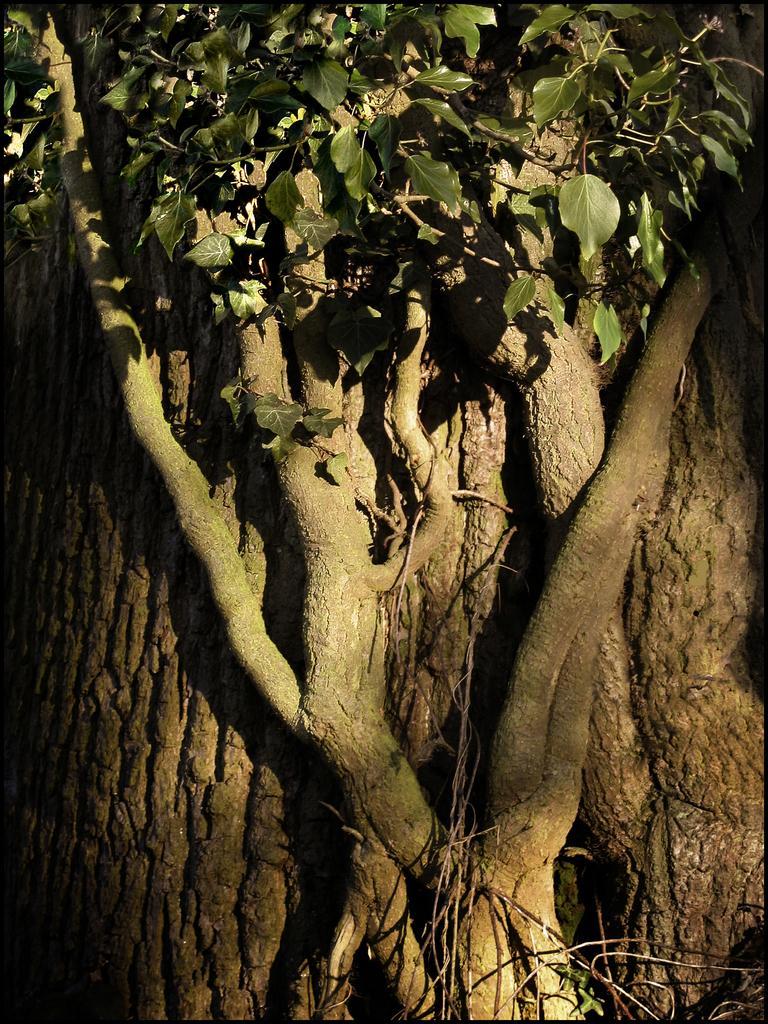Describe this image in one or two sentences. In this picture we can see partially covered tree with leaves. 